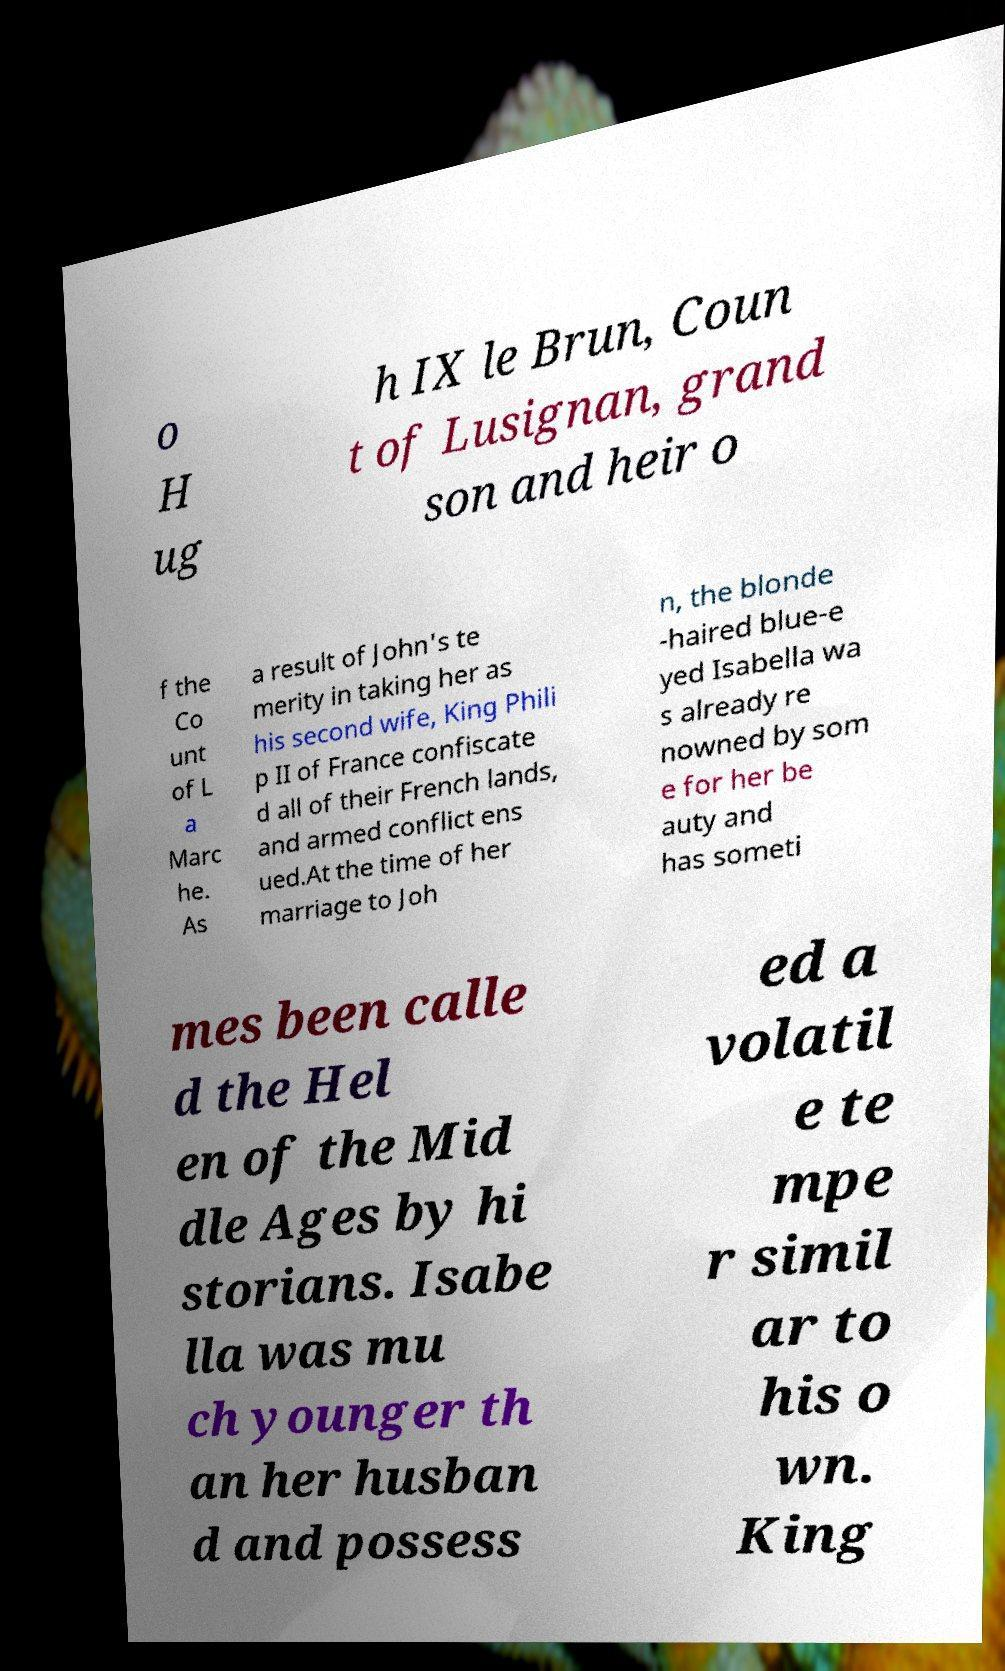Could you extract and type out the text from this image? o H ug h IX le Brun, Coun t of Lusignan, grand son and heir o f the Co unt of L a Marc he. As a result of John's te merity in taking her as his second wife, King Phili p II of France confiscate d all of their French lands, and armed conflict ens ued.At the time of her marriage to Joh n, the blonde -haired blue-e yed Isabella wa s already re nowned by som e for her be auty and has someti mes been calle d the Hel en of the Mid dle Ages by hi storians. Isabe lla was mu ch younger th an her husban d and possess ed a volatil e te mpe r simil ar to his o wn. King 